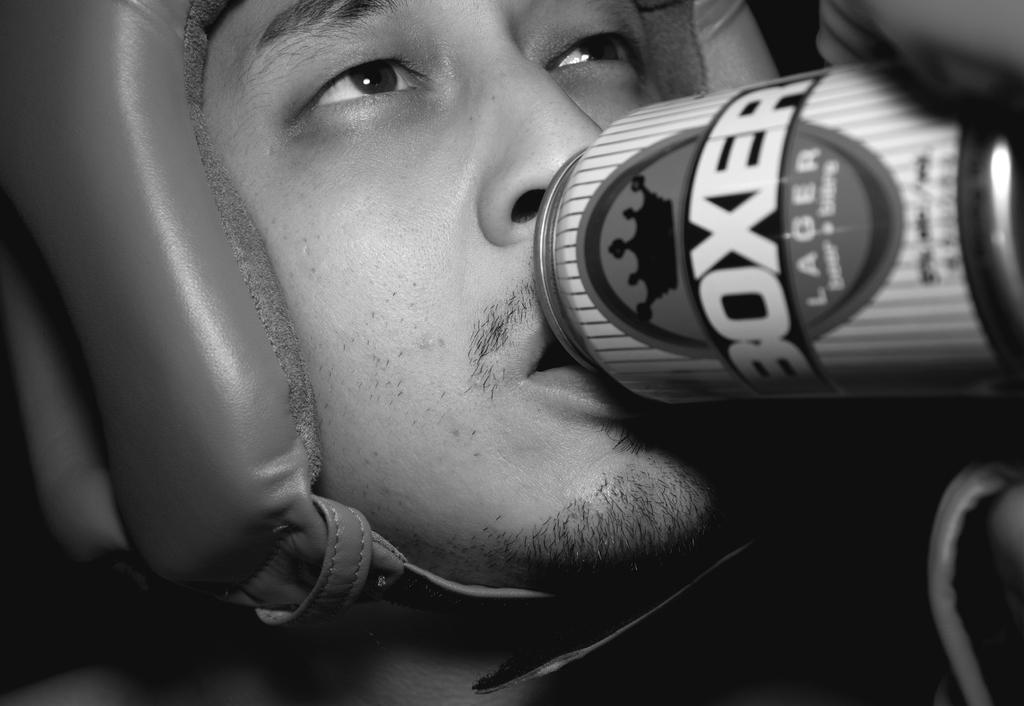<image>
Share a concise interpretation of the image provided. A man with a boxing helmet drinks from a can labeled BOXER. 